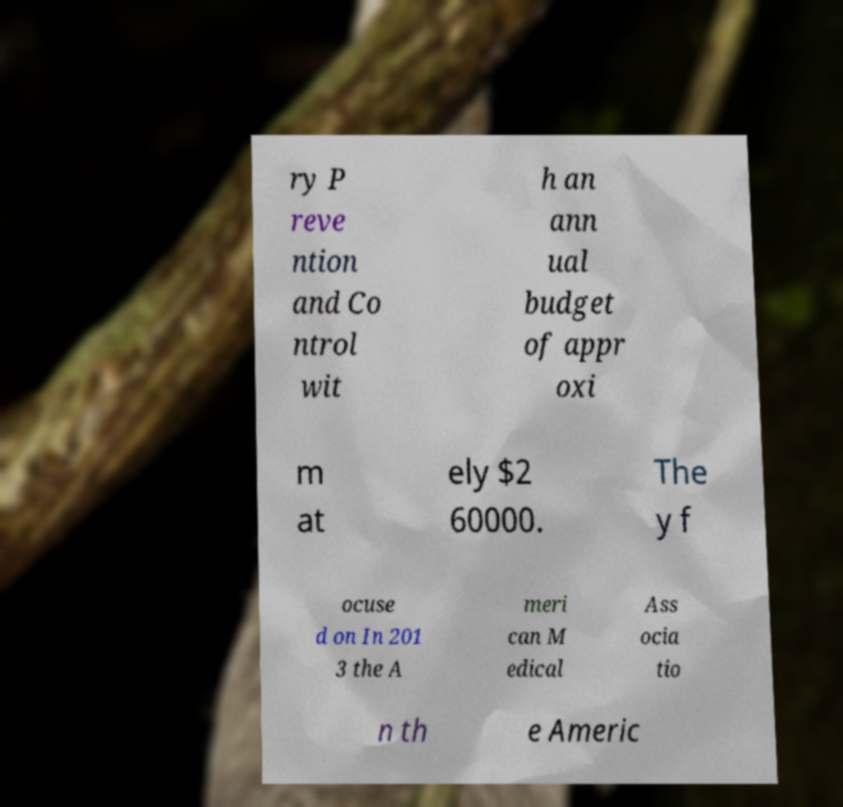What messages or text are displayed in this image? I need them in a readable, typed format. ry P reve ntion and Co ntrol wit h an ann ual budget of appr oxi m at ely $2 60000. The y f ocuse d on In 201 3 the A meri can M edical Ass ocia tio n th e Americ 